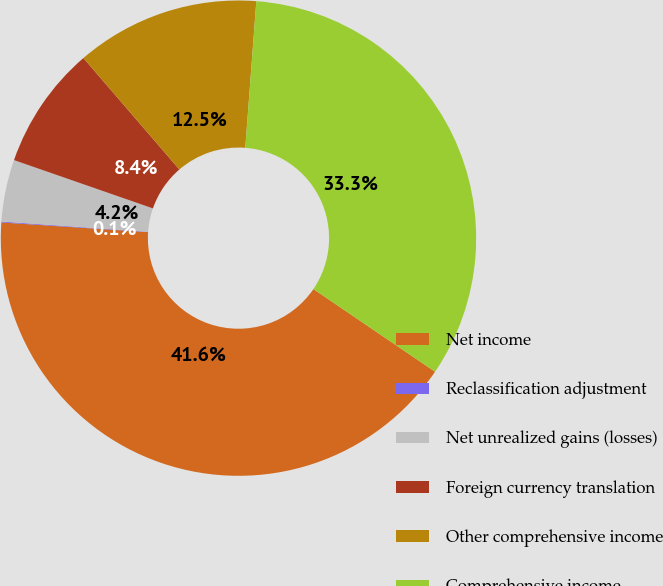Convert chart to OTSL. <chart><loc_0><loc_0><loc_500><loc_500><pie_chart><fcel>Net income<fcel>Reclassification adjustment<fcel>Net unrealized gains (losses)<fcel>Foreign currency translation<fcel>Other comprehensive income<fcel>Comprehensive income<nl><fcel>41.55%<fcel>0.06%<fcel>4.21%<fcel>8.36%<fcel>12.51%<fcel>33.3%<nl></chart> 